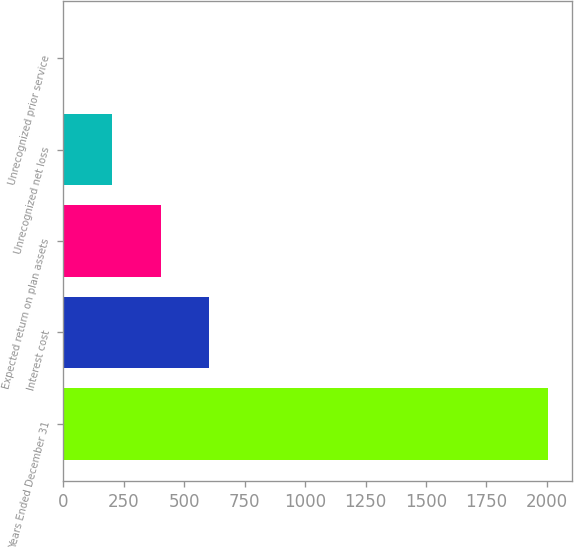Convert chart to OTSL. <chart><loc_0><loc_0><loc_500><loc_500><bar_chart><fcel>Years Ended December 31<fcel>Interest cost<fcel>Expected return on plan assets<fcel>Unrecognized net loss<fcel>Unrecognized prior service<nl><fcel>2005<fcel>603.6<fcel>403.4<fcel>203.2<fcel>3<nl></chart> 